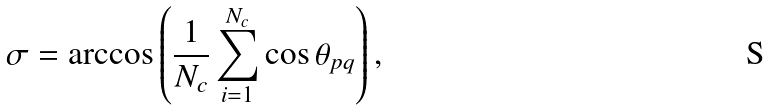<formula> <loc_0><loc_0><loc_500><loc_500>\sigma = \arccos \left ( \frac { 1 } { N _ { c } } \sum _ { i = 1 } ^ { N _ { c } } \cos \theta _ { p q } \right ) ,</formula> 